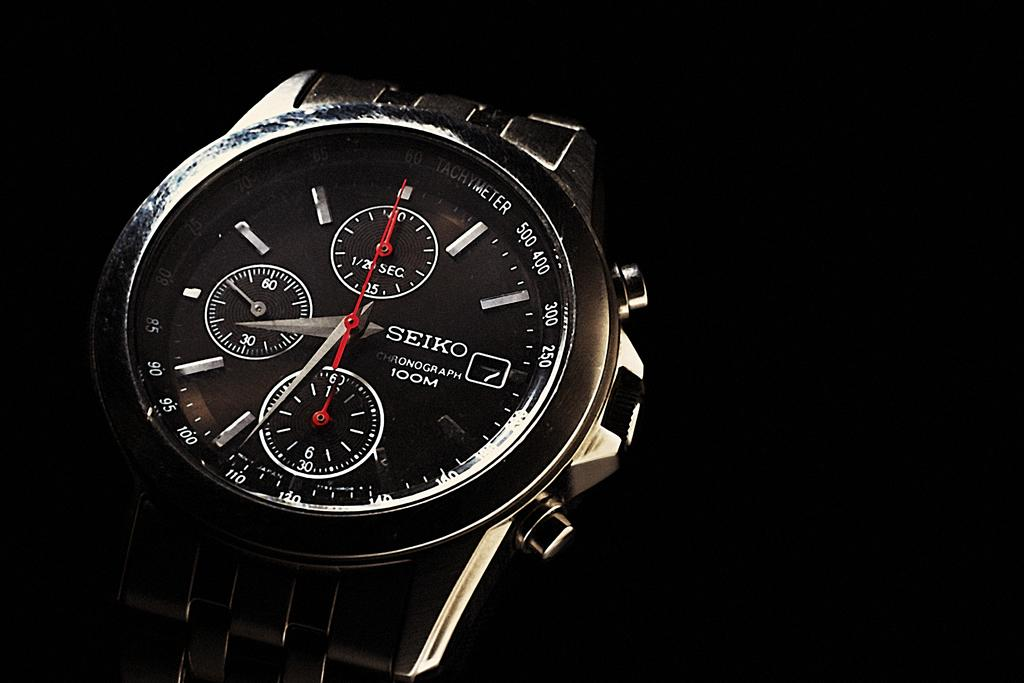Provide a one-sentence caption for the provided image. A black luxury Seiko brand watch with a silver chain band. 